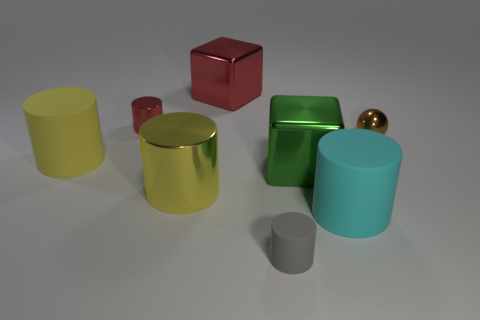Subtract all red cylinders. How many cylinders are left? 4 Subtract all gray cylinders. How many cylinders are left? 4 Subtract all gray cylinders. Subtract all cyan blocks. How many cylinders are left? 4 Add 1 purple metal blocks. How many objects exist? 9 Subtract all cylinders. How many objects are left? 3 Subtract all green cubes. Subtract all small rubber balls. How many objects are left? 7 Add 6 tiny red cylinders. How many tiny red cylinders are left? 7 Add 3 big yellow metal things. How many big yellow metal things exist? 4 Subtract 0 red balls. How many objects are left? 8 